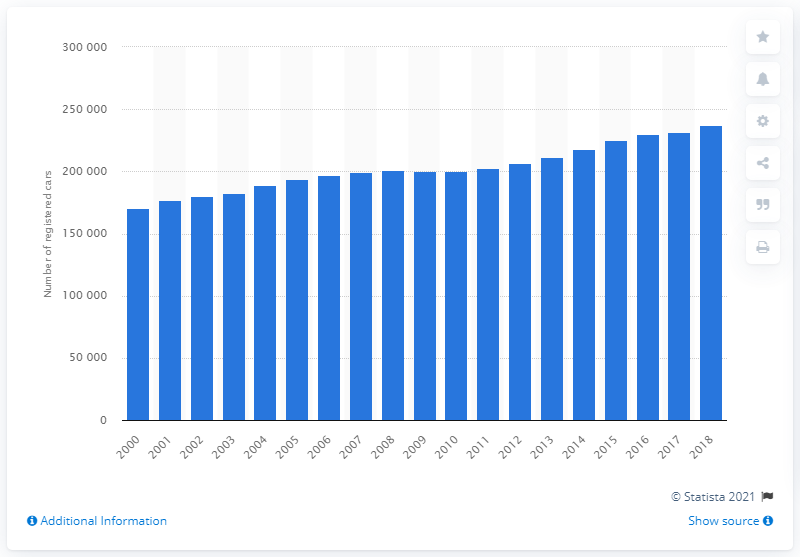Highlight a few significant elements in this photo. In the year 2000, a total of 170,710 cars were registered in Great Britain. In 2018, a total of 237,149 cars were registered in Great Britain. 